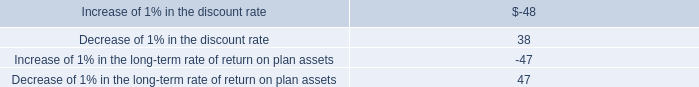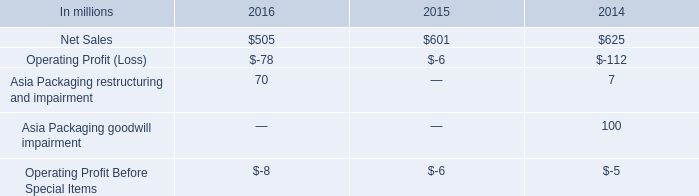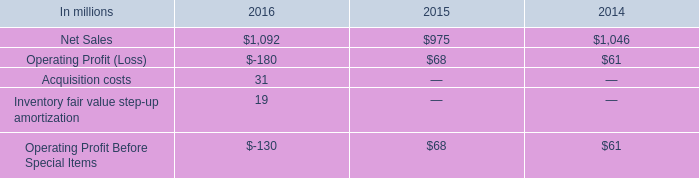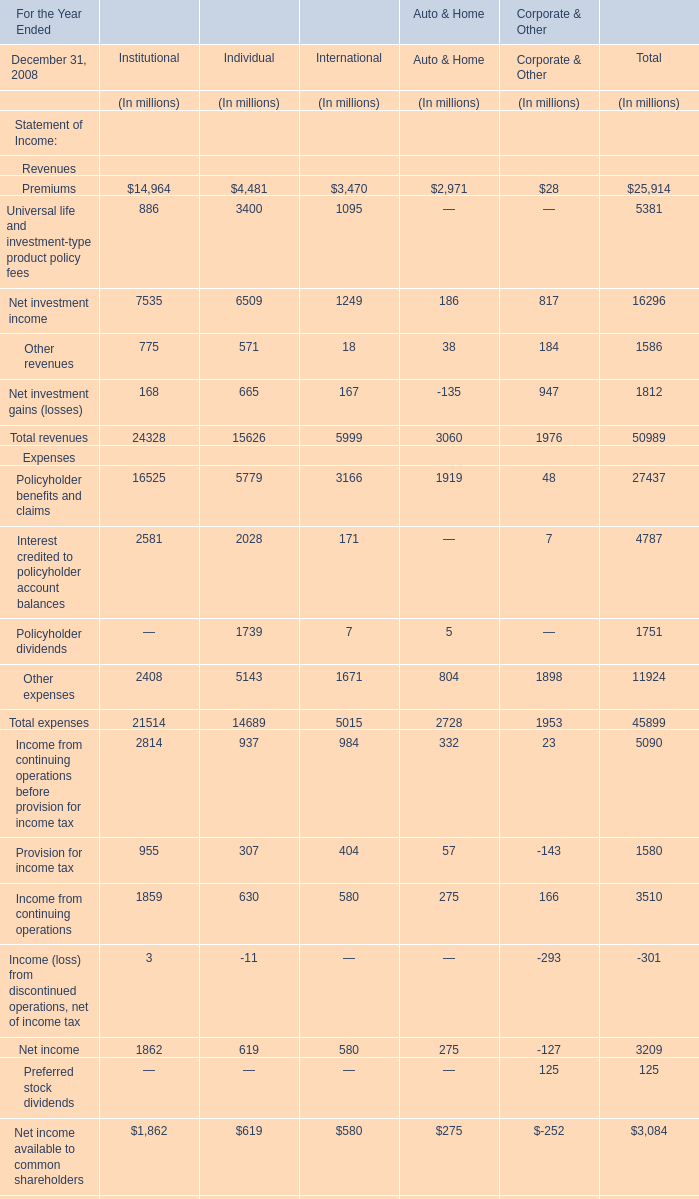How many elements for Individual show negative value in 2008? 
Answer: 1. 